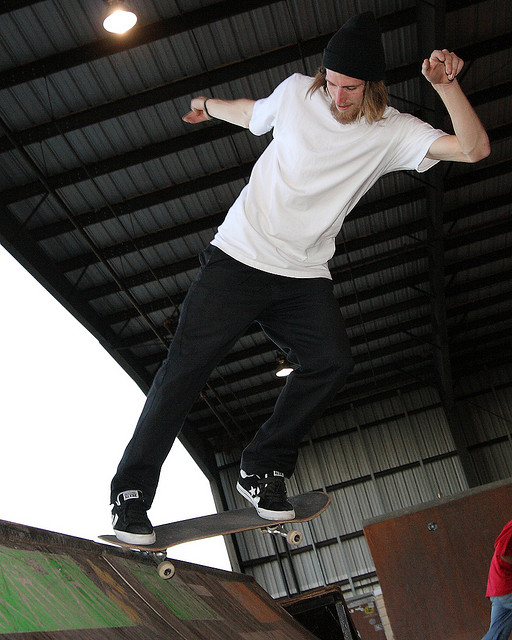<image>What design is on the skateboard? I am not sure what design is on the skateboard. It could be plain or have grip tape. What design is on the skateboard? I am not sure what design is on the skateboard. It can be seen plain, black grip tape, no design or unknown. 